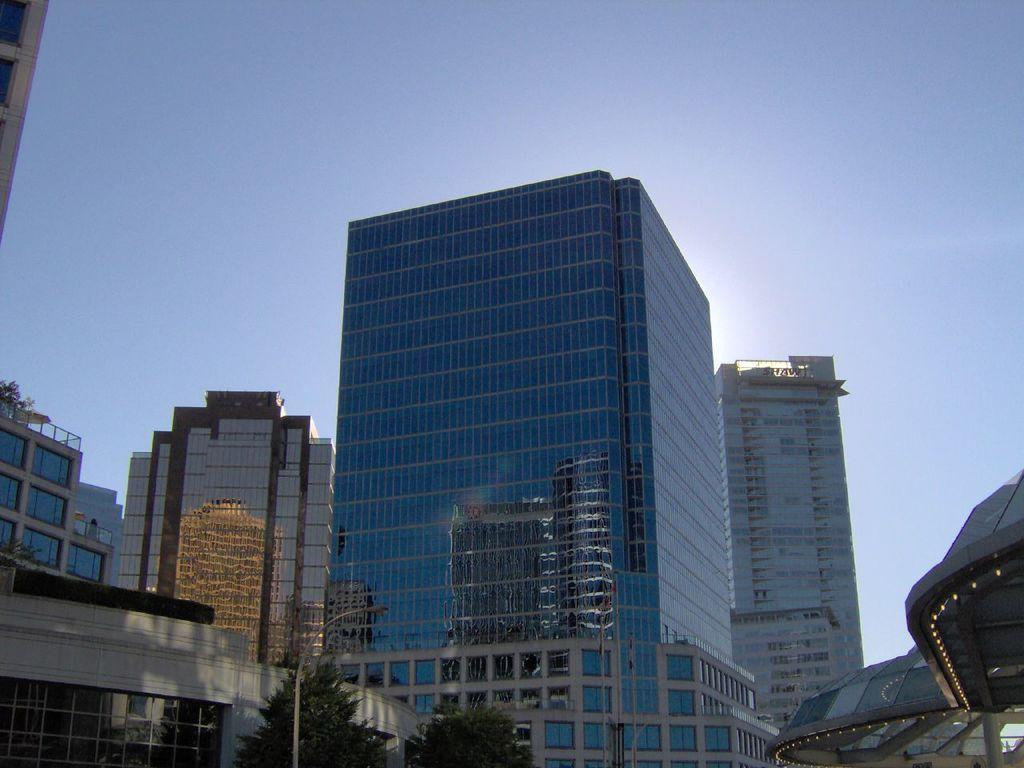What type of structures can be seen in the image? There are buildings in the image. What natural elements are present in the image? There are trees in the image. What object is located in the front of the image? There is a pole in the front of the image. What type of turkey can be seen roaming around the buildings in the image? There is no turkey present in the image; it only features buildings, trees, and a pole. 